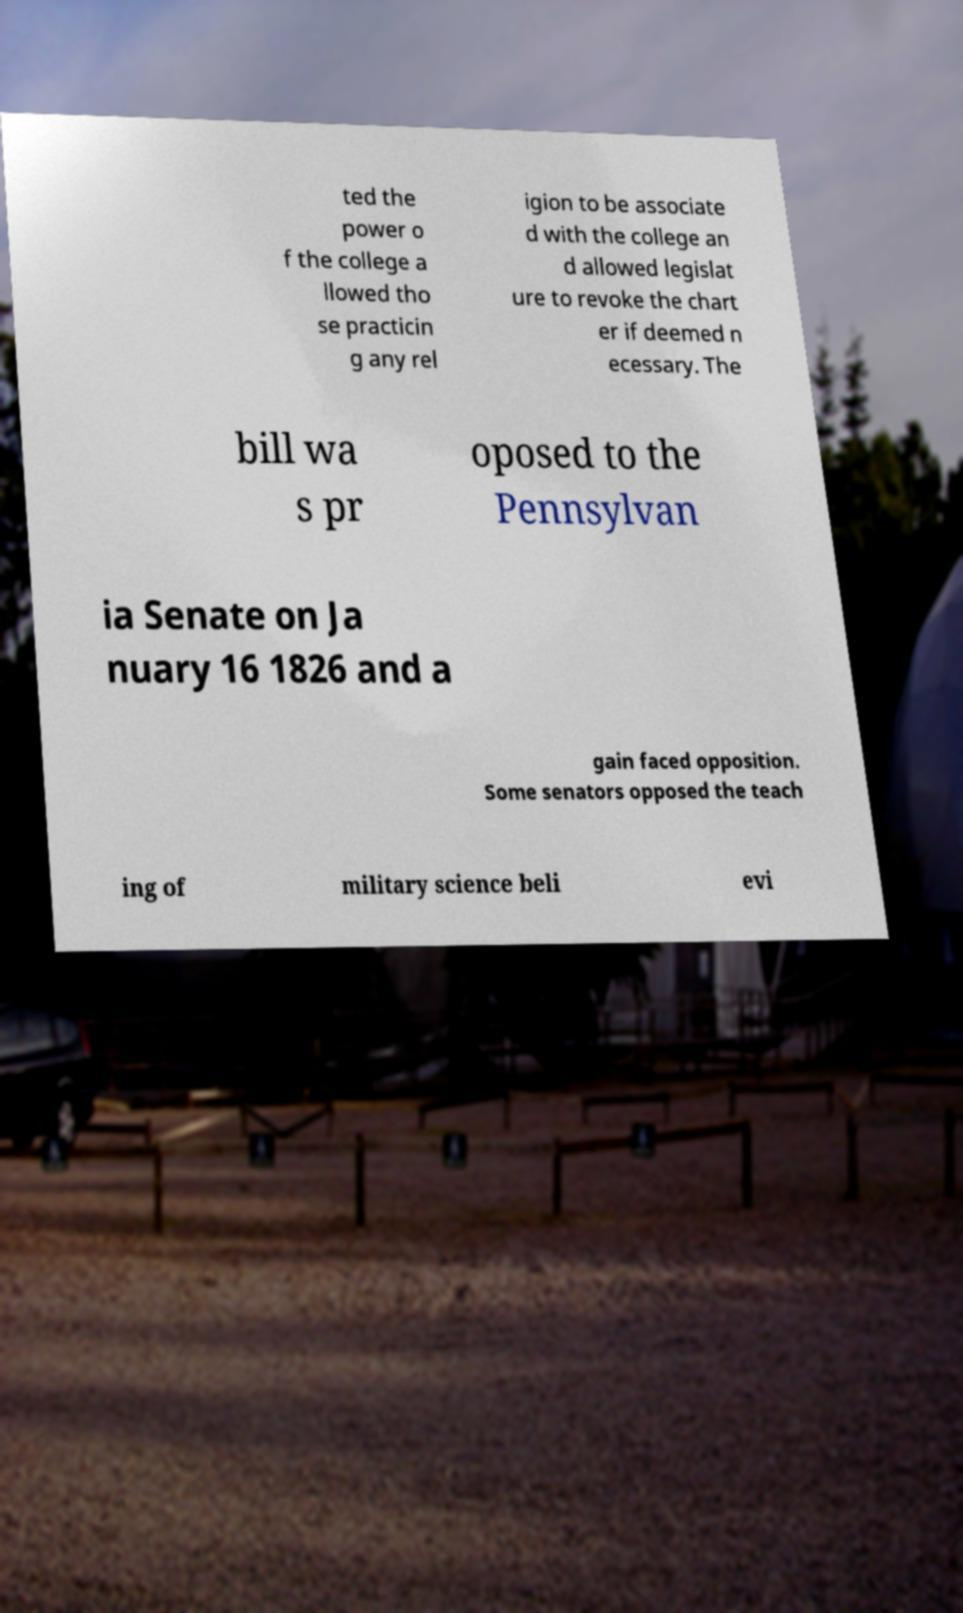Could you assist in decoding the text presented in this image and type it out clearly? ted the power o f the college a llowed tho se practicin g any rel igion to be associate d with the college an d allowed legislat ure to revoke the chart er if deemed n ecessary. The bill wa s pr oposed to the Pennsylvan ia Senate on Ja nuary 16 1826 and a gain faced opposition. Some senators opposed the teach ing of military science beli evi 